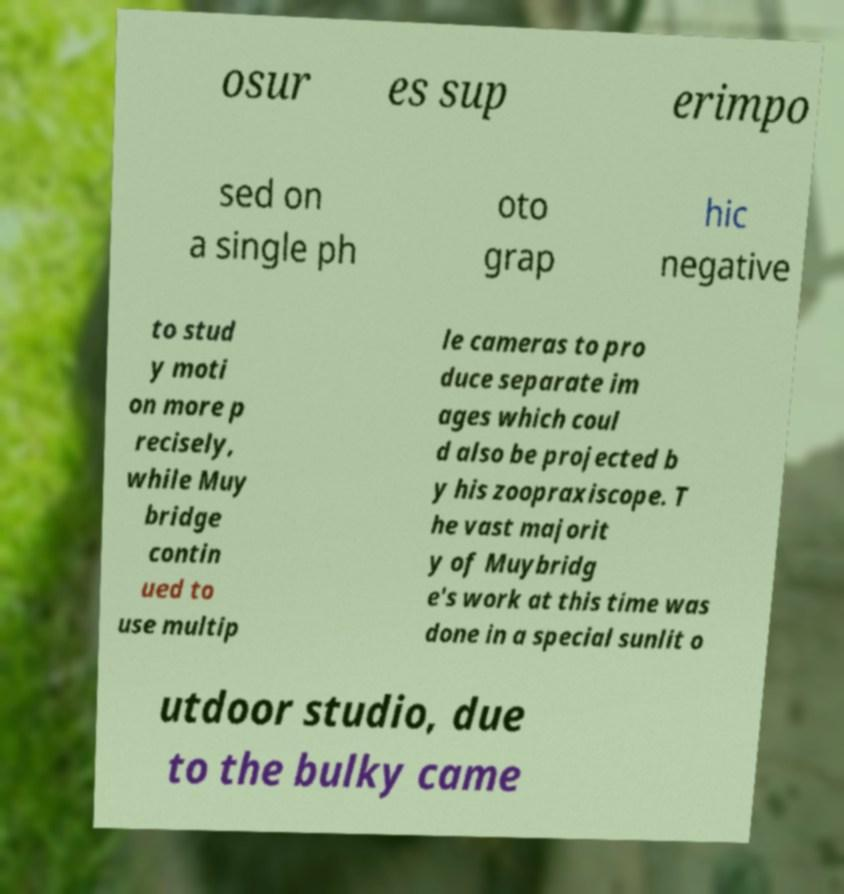Please read and relay the text visible in this image. What does it say? osur es sup erimpo sed on a single ph oto grap hic negative to stud y moti on more p recisely, while Muy bridge contin ued to use multip le cameras to pro duce separate im ages which coul d also be projected b y his zoopraxiscope. T he vast majorit y of Muybridg e's work at this time was done in a special sunlit o utdoor studio, due to the bulky came 